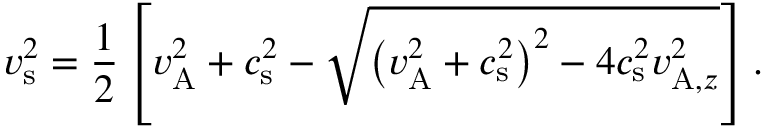Convert formula to latex. <formula><loc_0><loc_0><loc_500><loc_500>v _ { s } ^ { 2 } = \frac { 1 } { 2 } \left [ v _ { A } ^ { 2 } + c _ { s } ^ { 2 } - \sqrt { \left ( v _ { A } ^ { 2 } + c _ { s } ^ { 2 } \right ) ^ { 2 } - 4 c _ { s } ^ { 2 } v _ { A , z } ^ { 2 } } \right ] .</formula> 